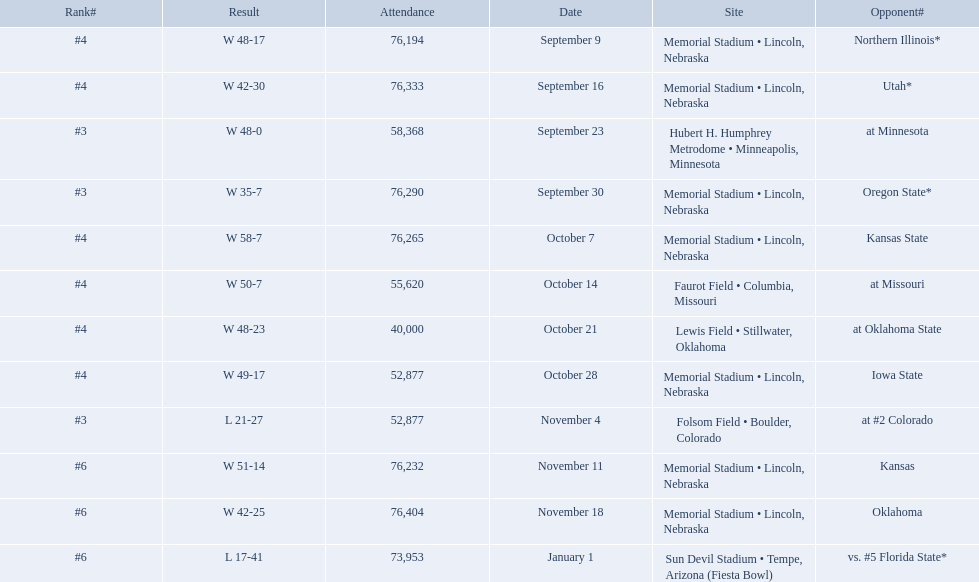When did nebraska play oregon state? September 30. What was the attendance at the september 30 game? 76,290. 